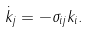Convert formula to latex. <formula><loc_0><loc_0><loc_500><loc_500>\dot { k } _ { j } = - \sigma _ { i j } k _ { i } .</formula> 